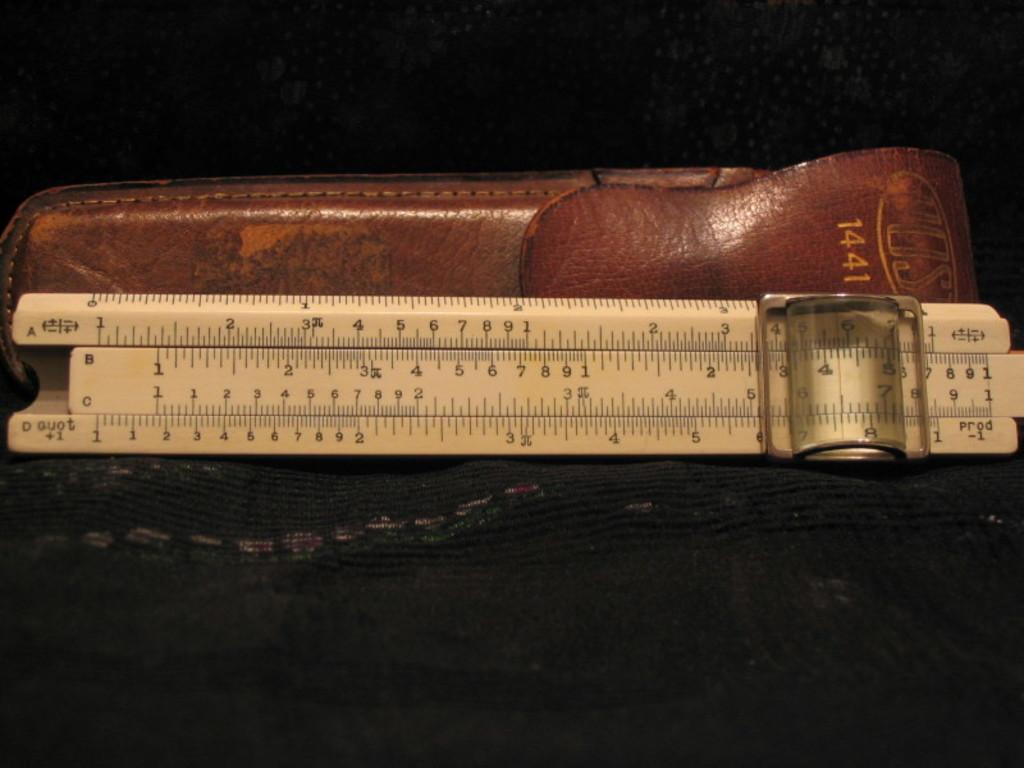What year is labeled on the leather holder?
Make the answer very short. 1441. What measurement is marked on the ruler?
Provide a succinct answer. 6. 